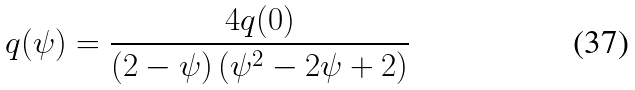<formula> <loc_0><loc_0><loc_500><loc_500>q ( \psi ) = \frac { 4 q ( 0 ) } { \left ( 2 - \psi \right ) \left ( \psi ^ { 2 } - 2 \psi + 2 \right ) }</formula> 